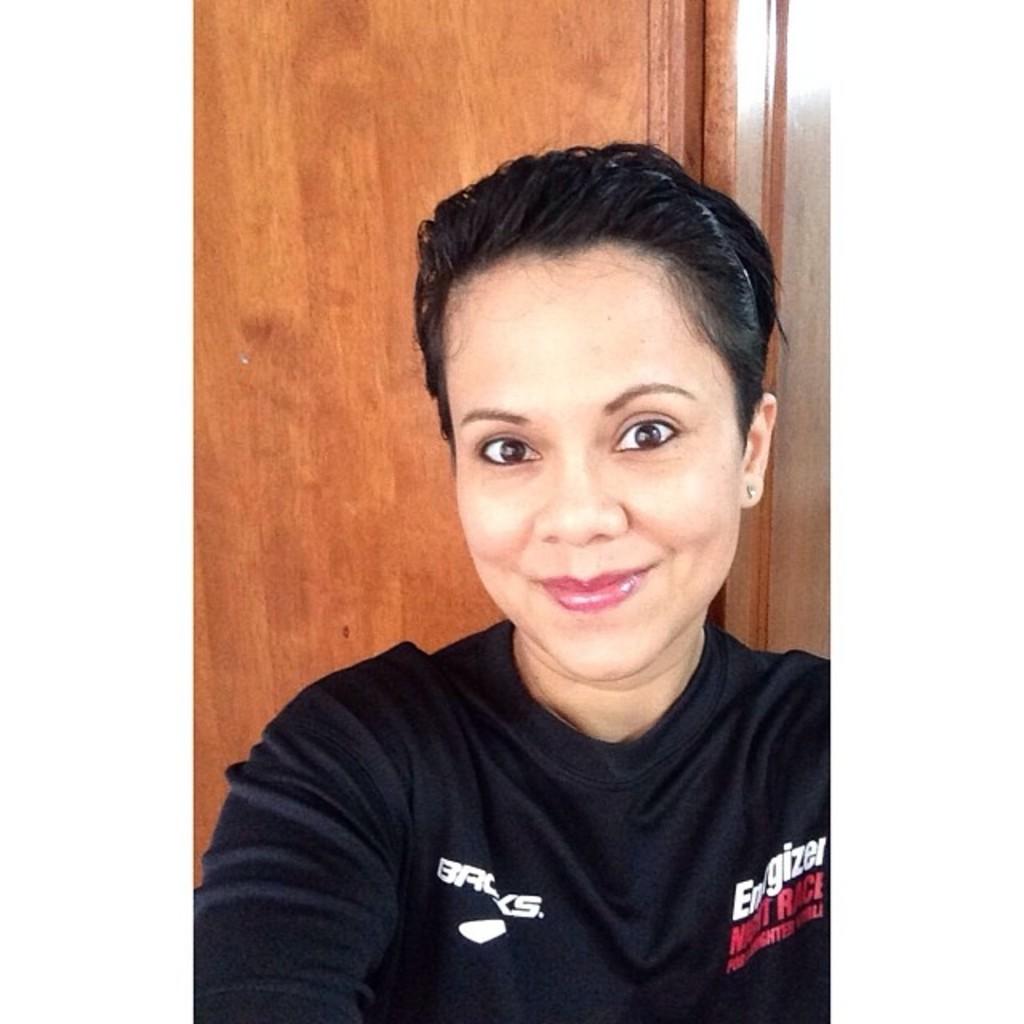What battery brand is shown on the shirt?
Provide a short and direct response. Energizer. 